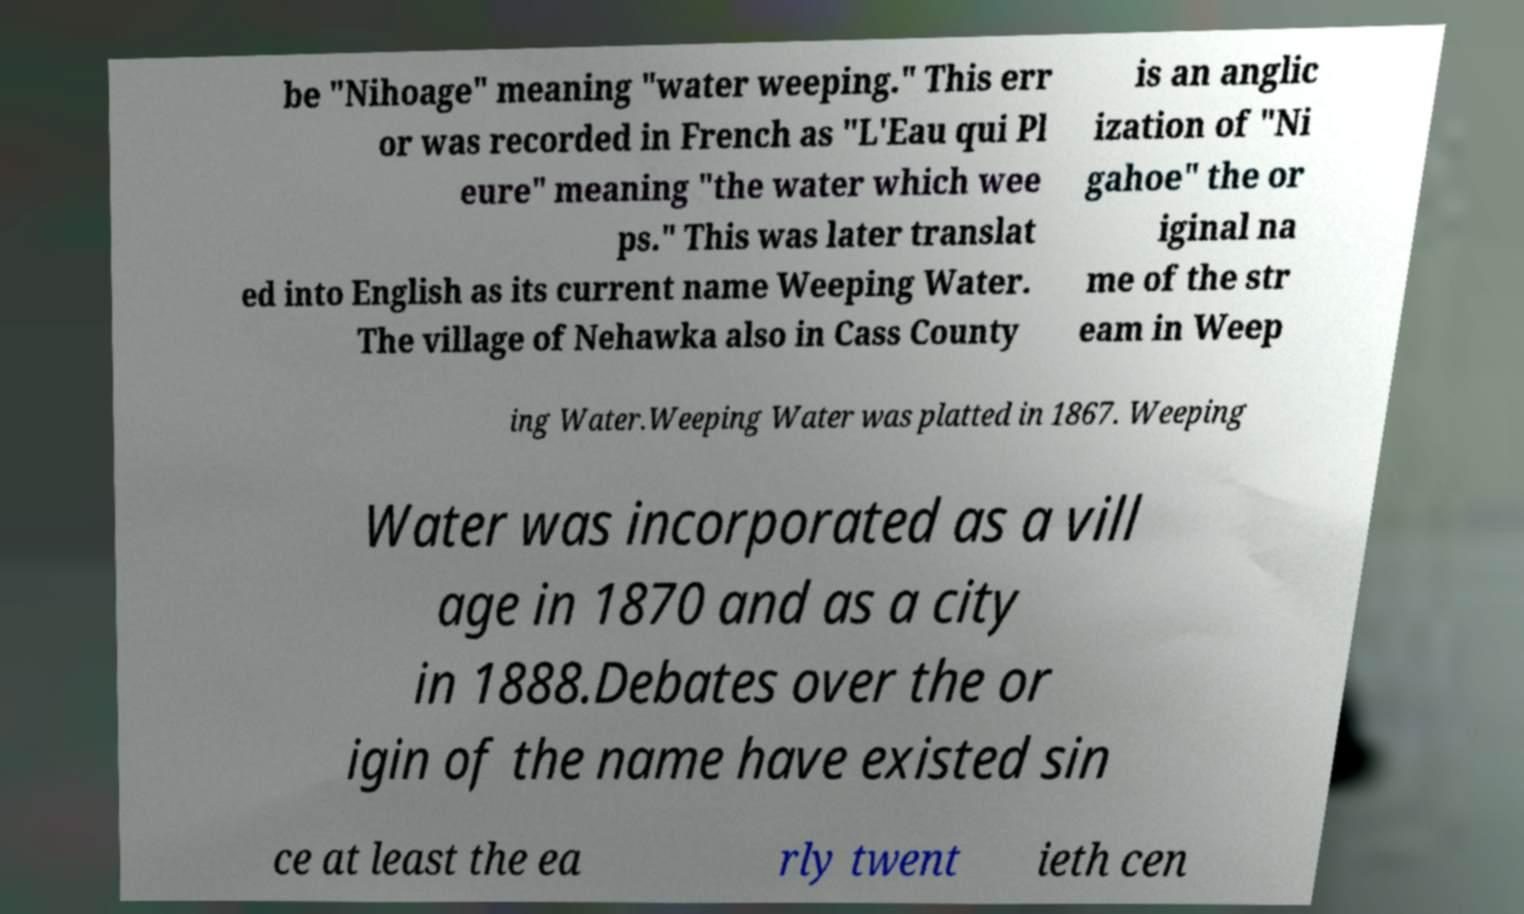Can you accurately transcribe the text from the provided image for me? be "Nihoage" meaning "water weeping." This err or was recorded in French as "L'Eau qui Pl eure" meaning "the water which wee ps." This was later translat ed into English as its current name Weeping Water. The village of Nehawka also in Cass County is an anglic ization of "Ni gahoe" the or iginal na me of the str eam in Weep ing Water.Weeping Water was platted in 1867. Weeping Water was incorporated as a vill age in 1870 and as a city in 1888.Debates over the or igin of the name have existed sin ce at least the ea rly twent ieth cen 